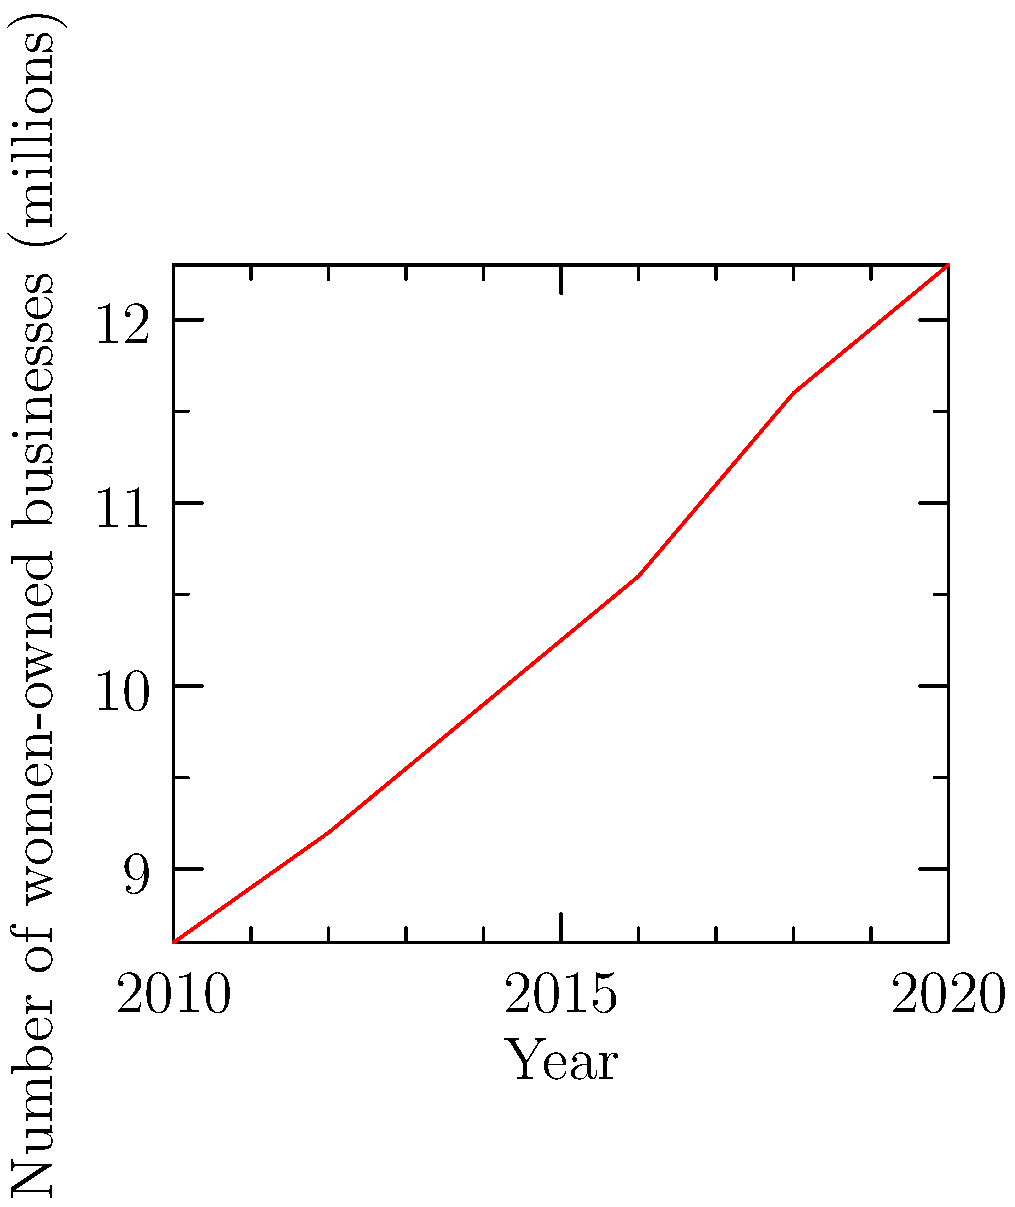Based on the line graph showing the growth of women-owned businesses from 2010 to 2020, calculate the average annual increase in the number of women-owned businesses during this period. To calculate the average annual increase in women-owned businesses:

1. Calculate total increase:
   2020 value: 12.3 million
   2010 value: 8.6 million
   Total increase: 12.3 - 8.6 = 3.7 million

2. Determine the number of years:
   2020 - 2010 = 10 years

3. Calculate average annual increase:
   Average annual increase = Total increase ÷ Number of years
   $\frac{3.7 \text{ million}}{10 \text{ years}} = 0.37 \text{ million per year}$

4. Convert to thousands for a more manageable number:
   0.37 million = 370 thousand

Thus, the average annual increase in women-owned businesses from 2010 to 2020 was 370 thousand per year.
Answer: 370,000 businesses per year 